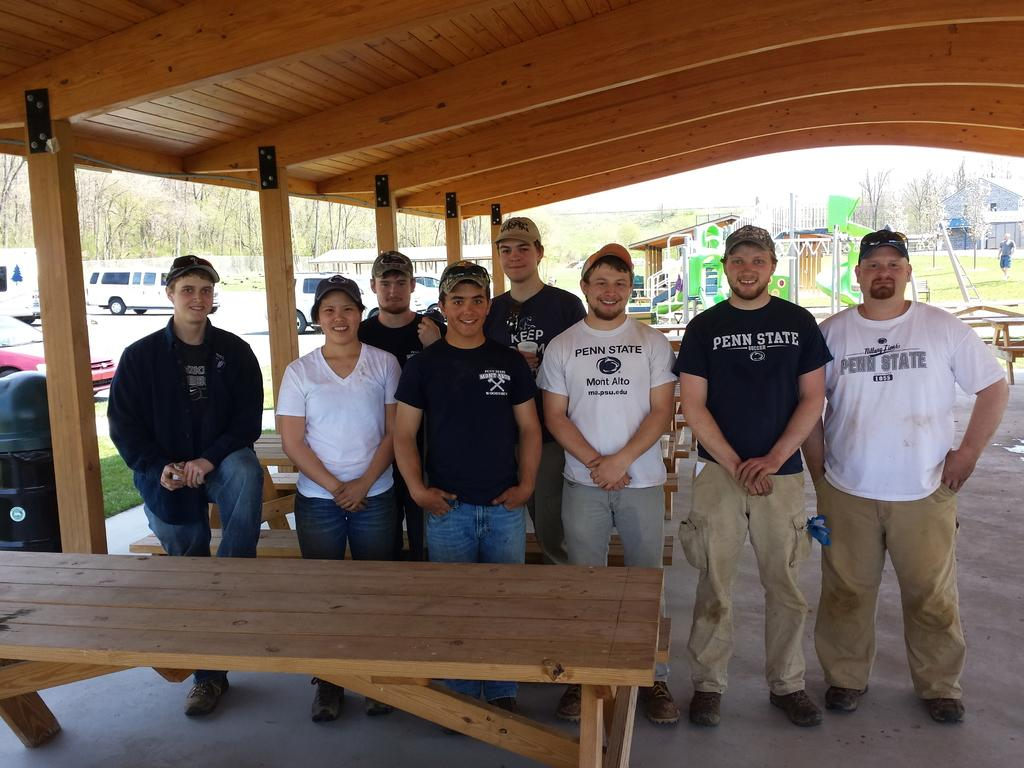How many people are in the image? There is a group of persons in the image. What are the persons wearing on their heads? The persons are wearing caps. What is in front of the group of persons? The persons are standing in front of a table. What can be seen in the distance behind the group of persons? There are cars and trees in the background of the image. Can you see any clovers growing on the table in the image? There are no clovers visible in the image; the focus is on the group of persons and the table in front of them. 